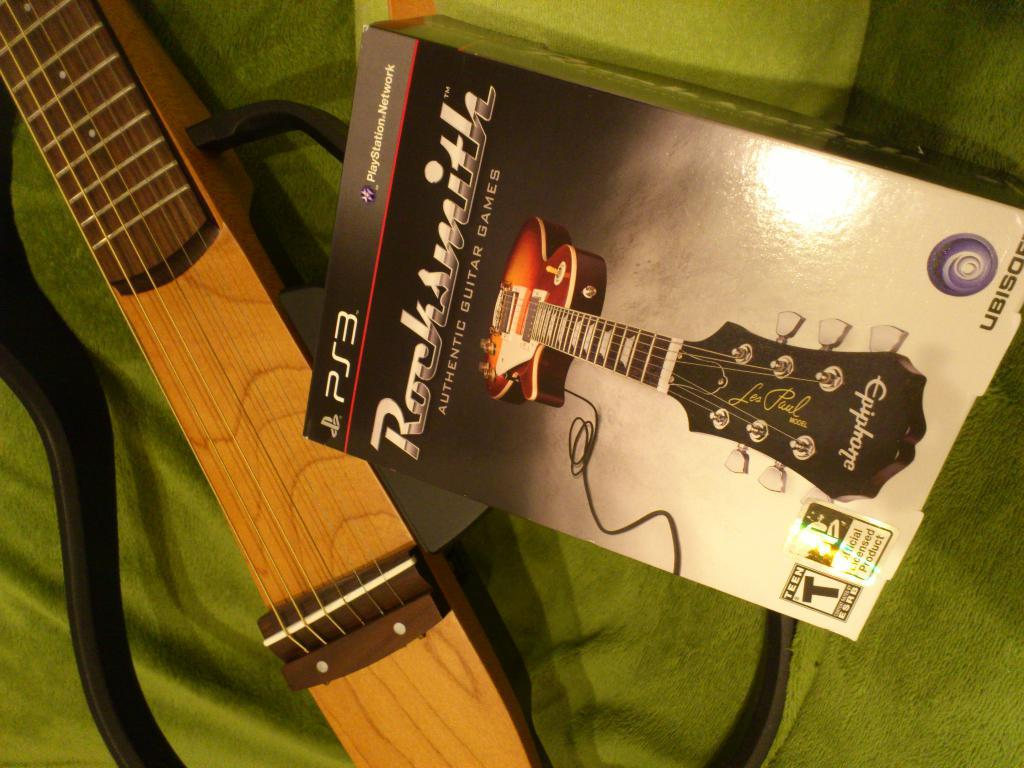<image>
Create a compact narrative representing the image presented. A guitar and a Rocksmith PS3 game sit on a bed. 